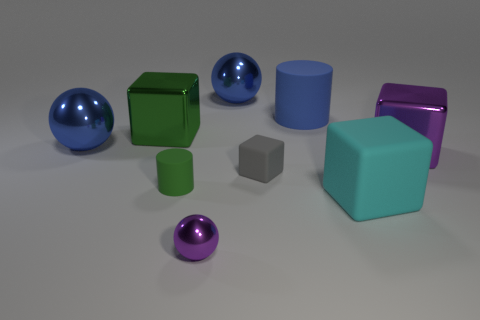Do the cylinder left of the tiny gray rubber object and the cube that is in front of the green rubber thing have the same material?
Provide a short and direct response. Yes. How many other objects are there of the same color as the big matte cube?
Give a very brief answer. 0. How many things are big blue spheres that are in front of the blue rubber cylinder or purple metallic objects in front of the big rubber cube?
Provide a short and direct response. 2. What size is the metallic sphere to the left of the purple shiny object that is in front of the big cyan thing?
Offer a terse response. Large. The green shiny block is what size?
Your answer should be very brief. Large. There is a cylinder that is to the right of the green matte cylinder; is it the same color as the shiny object that is on the right side of the big matte cube?
Provide a short and direct response. No. What number of other objects are the same material as the purple cube?
Offer a very short reply. 4. Are any big purple metal cubes visible?
Your answer should be compact. Yes. Does the green thing that is behind the small green object have the same material as the small cube?
Your answer should be very brief. No. What is the material of the gray object that is the same shape as the big cyan matte object?
Provide a short and direct response. Rubber. 